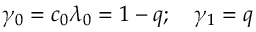<formula> <loc_0><loc_0><loc_500><loc_500>\gamma _ { 0 } = c _ { 0 } \lambda _ { 0 } = 1 - q ; \quad \gamma _ { 1 } = q</formula> 